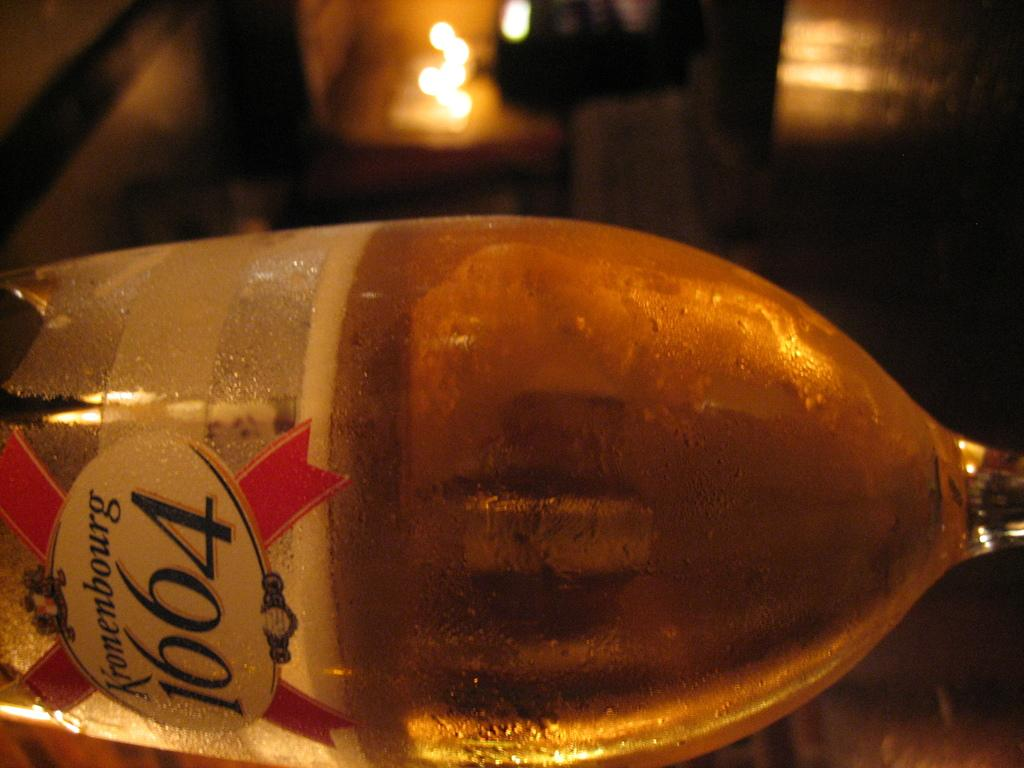What is the main subject of the image? The main subject of the image is a bottle. Can you describe the bottle in more detail? Unfortunately, the image only contains a zoomed-in picture of the bottle, so we cannot see the entire bottle or any labels or features. How many cherries are on top of the bottle in the image? There are no cherries present in the image, as it only contains a zoomed-in picture of a bottle. What type of cast is visible on the bottle in the image? There is no cast visible on the bottle in the image, as it only contains a zoomed-in picture of the bottle. 